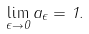Convert formula to latex. <formula><loc_0><loc_0><loc_500><loc_500>\lim _ { \epsilon \to 0 } a _ { \epsilon } = 1 .</formula> 